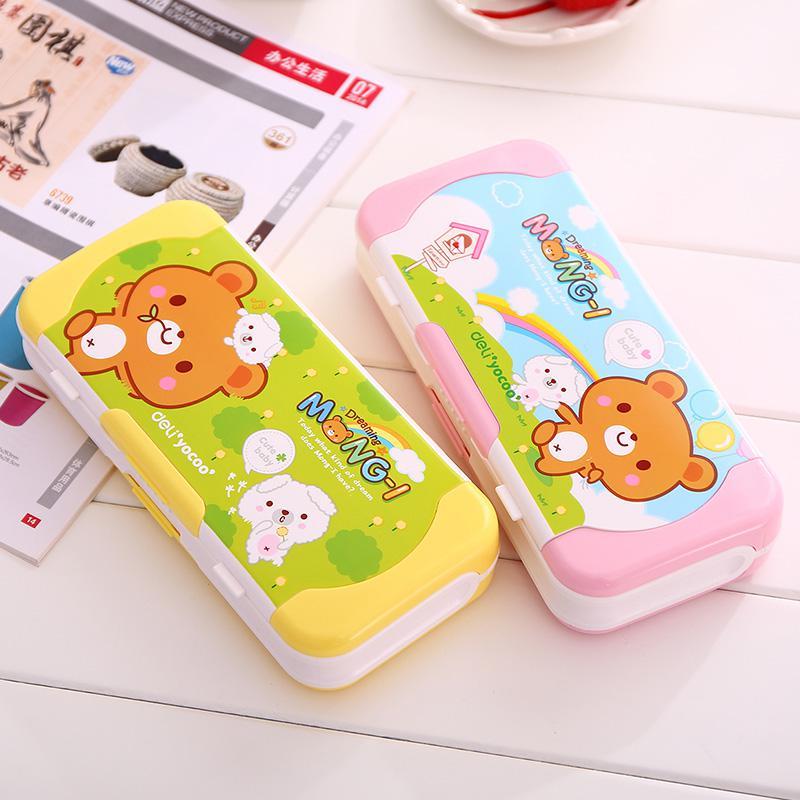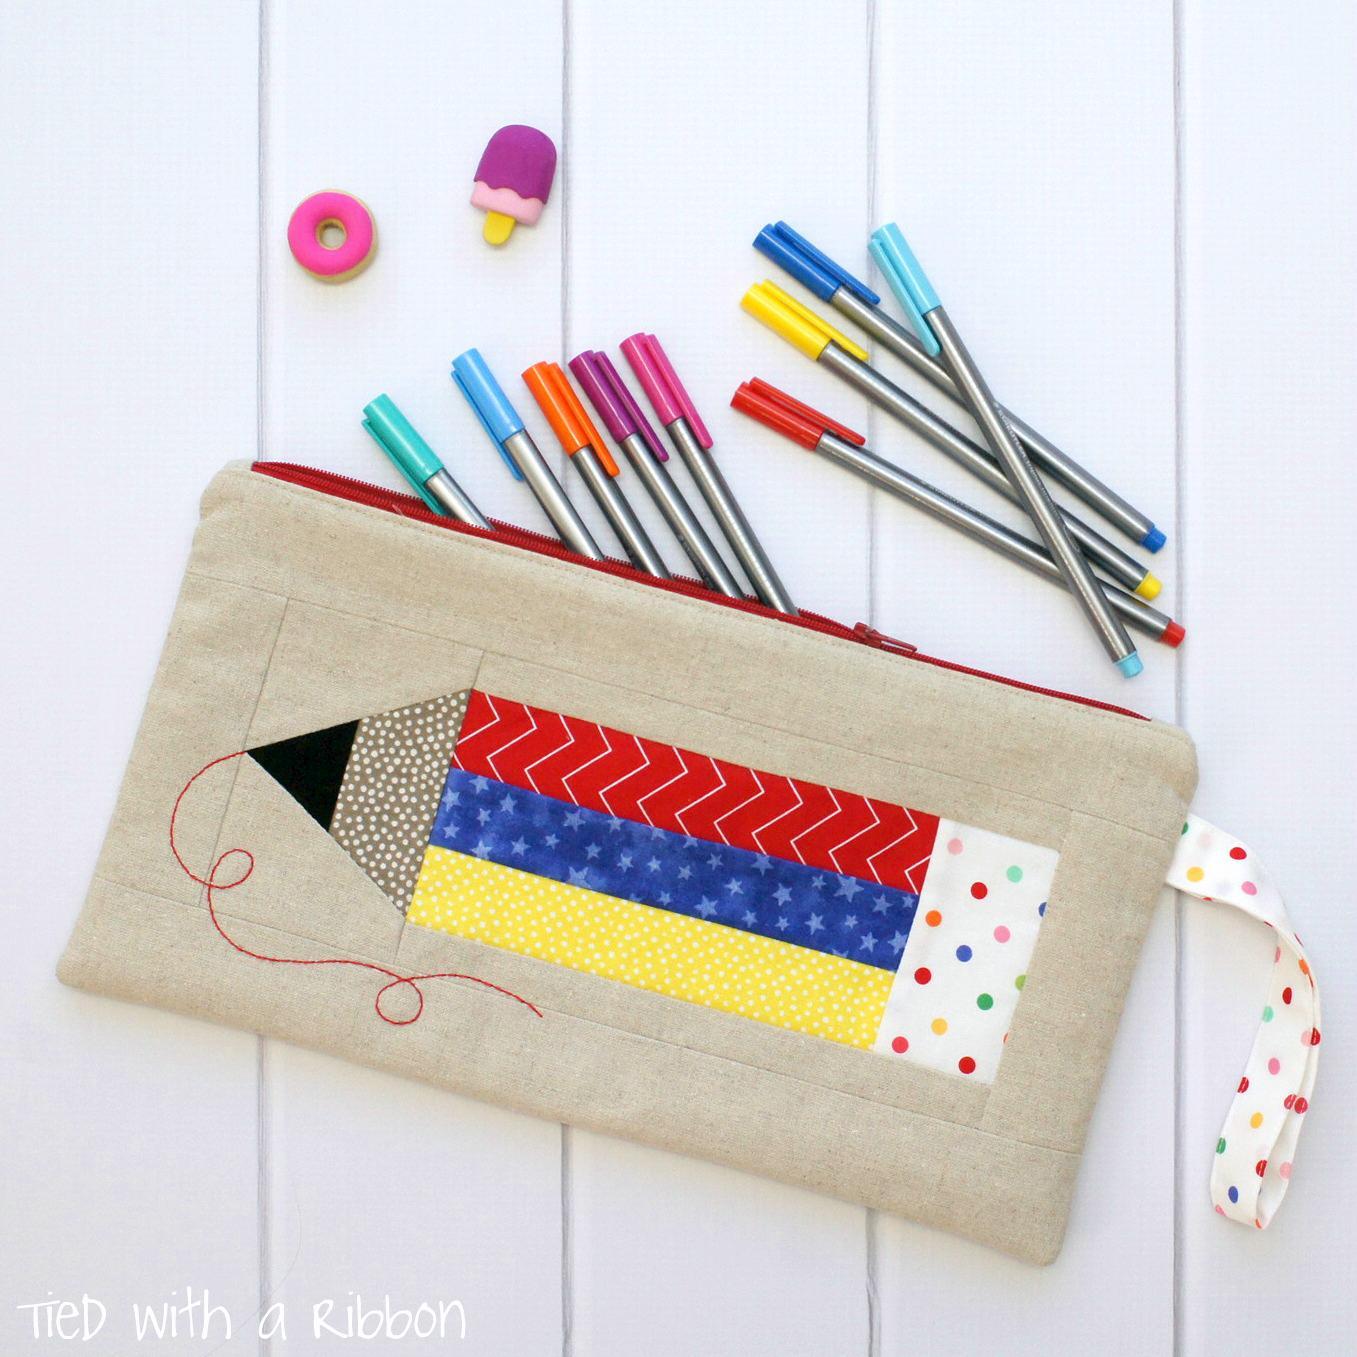The first image is the image on the left, the second image is the image on the right. Given the left and right images, does the statement "At least one pencil case has a brown bear on it." hold true? Answer yes or no. Yes. The first image is the image on the left, the second image is the image on the right. Analyze the images presented: Is the assertion "At least one of the pencil cases has a brown cartoon bear on it." valid? Answer yes or no. Yes. 